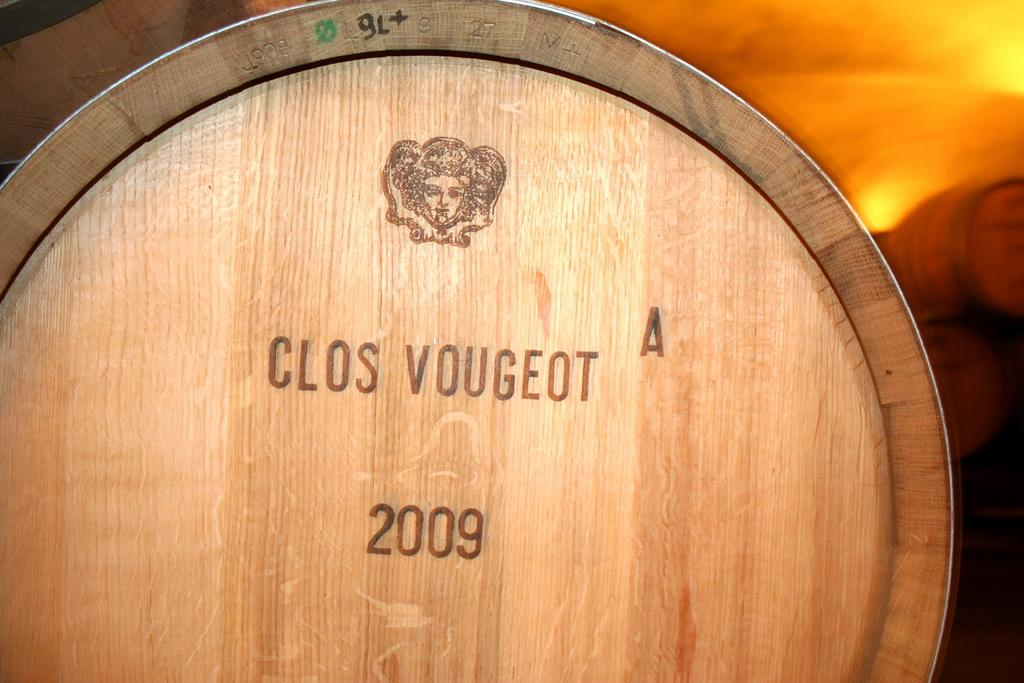<image>
Provide a brief description of the given image. A woode barrel that was sealed in the year 2009. 